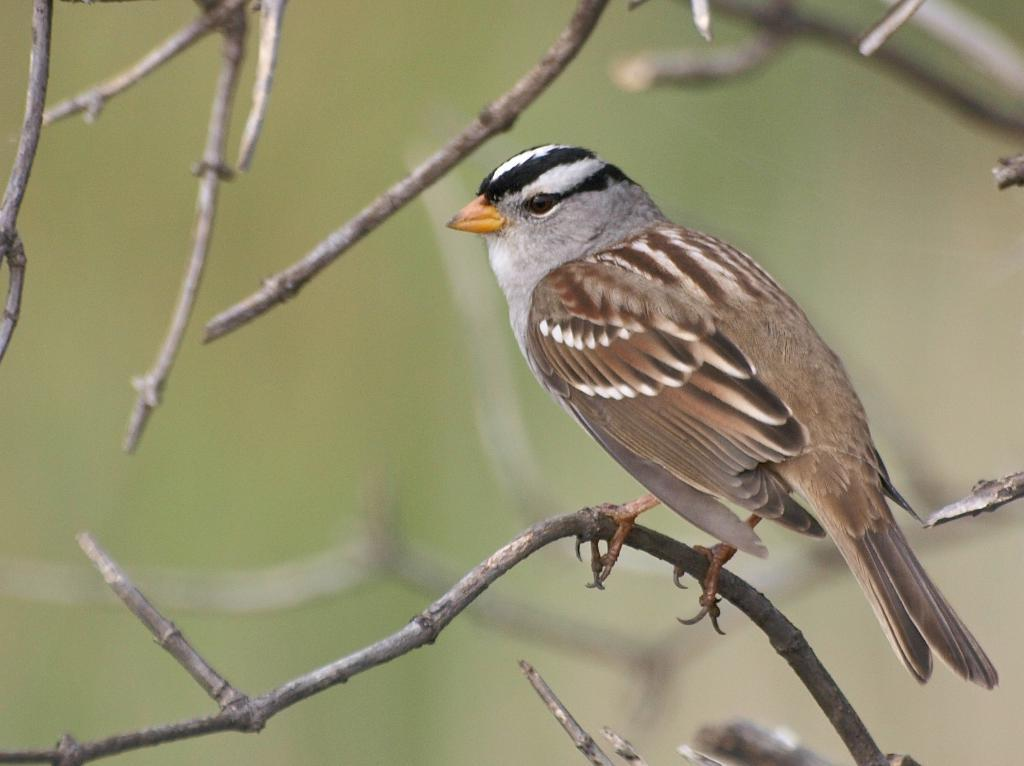What type of animal can be seen in the image? There is a bird in the image. Where is the bird located in the image? The bird is sitting on top of wood. What type of yarn is the bird using to pull the wood in the image? There is no yarn or pulling action involving the wood in the image; the bird is simply sitting on top of it. 